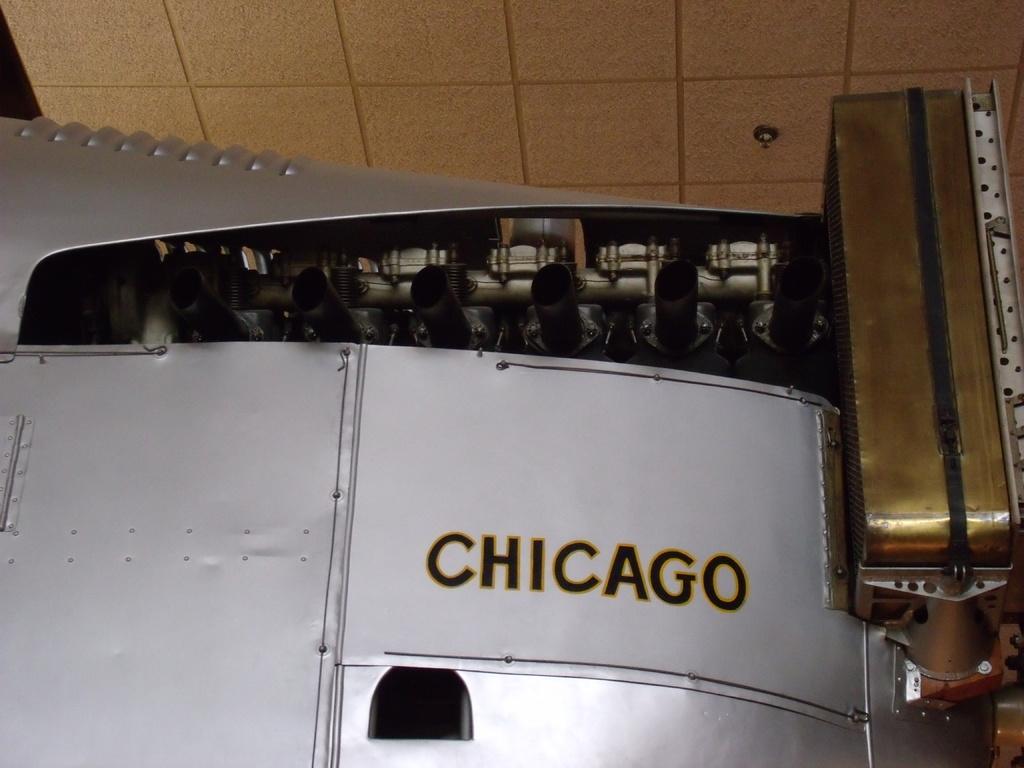What city is shown?
Ensure brevity in your answer.  Chicago. 